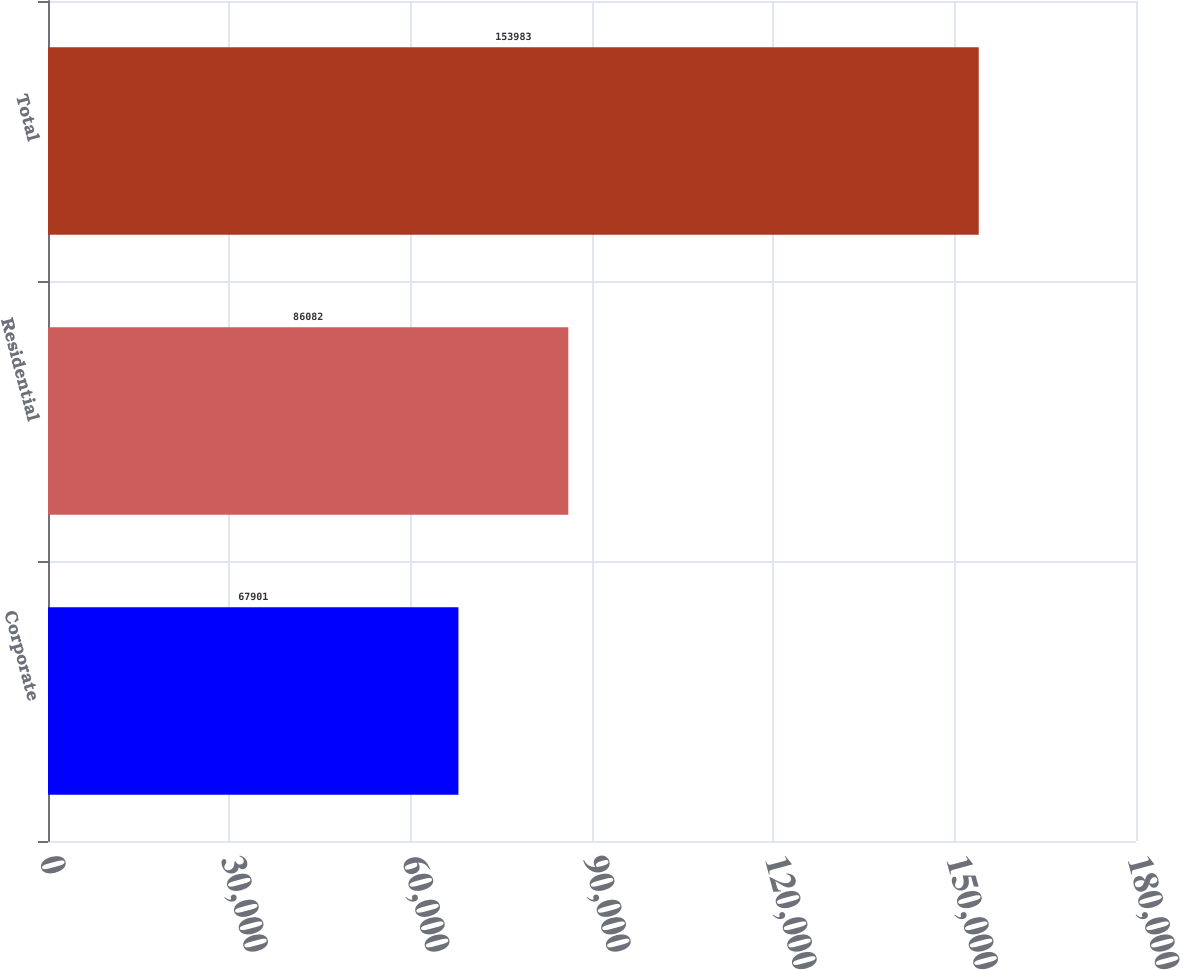Convert chart to OTSL. <chart><loc_0><loc_0><loc_500><loc_500><bar_chart><fcel>Corporate<fcel>Residential<fcel>Total<nl><fcel>67901<fcel>86082<fcel>153983<nl></chart> 